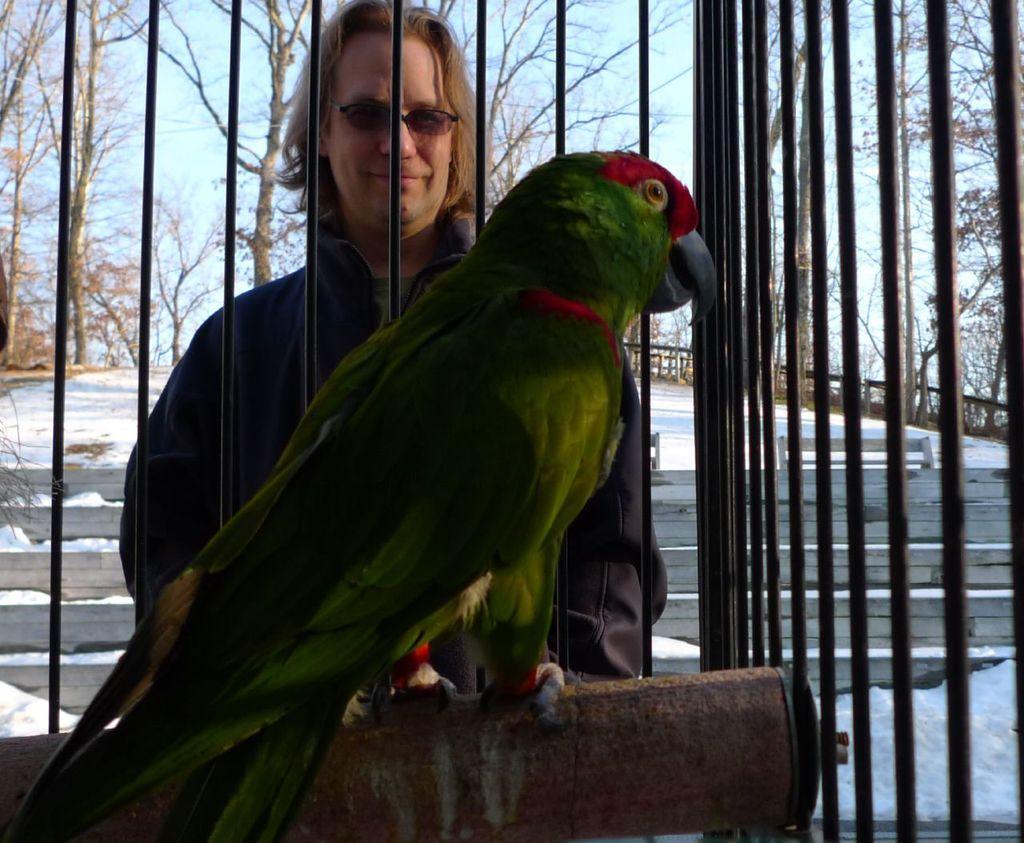Please provide a concise description of this image. In the image in the center we can see one cage. In cage,on rod we can see one parrot,which is in red and green color. In the background we can see sky,clouds,trees,road,fence,snow and one person standing and he is smiling. 